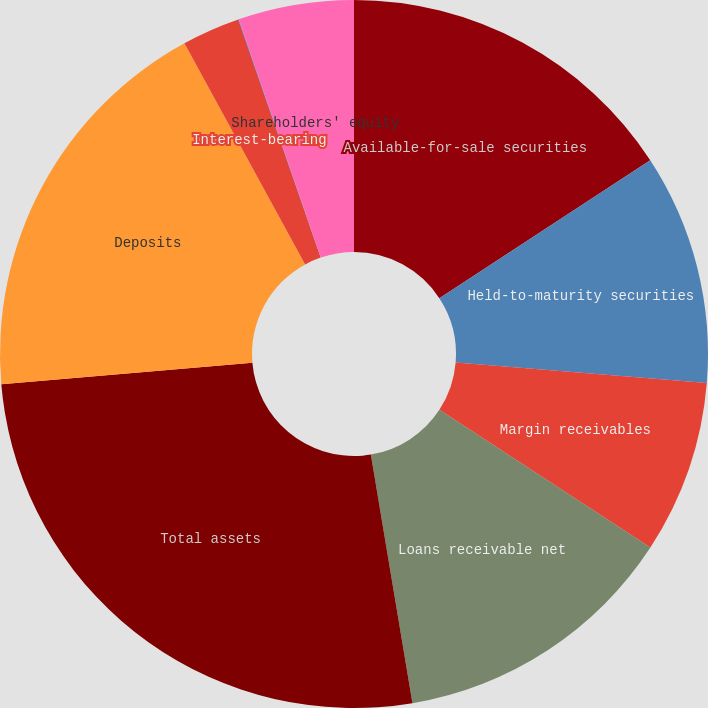<chart> <loc_0><loc_0><loc_500><loc_500><pie_chart><fcel>Available-for-sale securities<fcel>Held-to-maturity securities<fcel>Margin receivables<fcel>Loans receivable net<fcel>Total assets<fcel>Deposits<fcel>Interest-bearing<fcel>Non-interest-bearing<fcel>Shareholders' equity<nl><fcel>15.78%<fcel>10.53%<fcel>7.9%<fcel>13.15%<fcel>26.28%<fcel>18.41%<fcel>2.65%<fcel>0.02%<fcel>5.28%<nl></chart> 